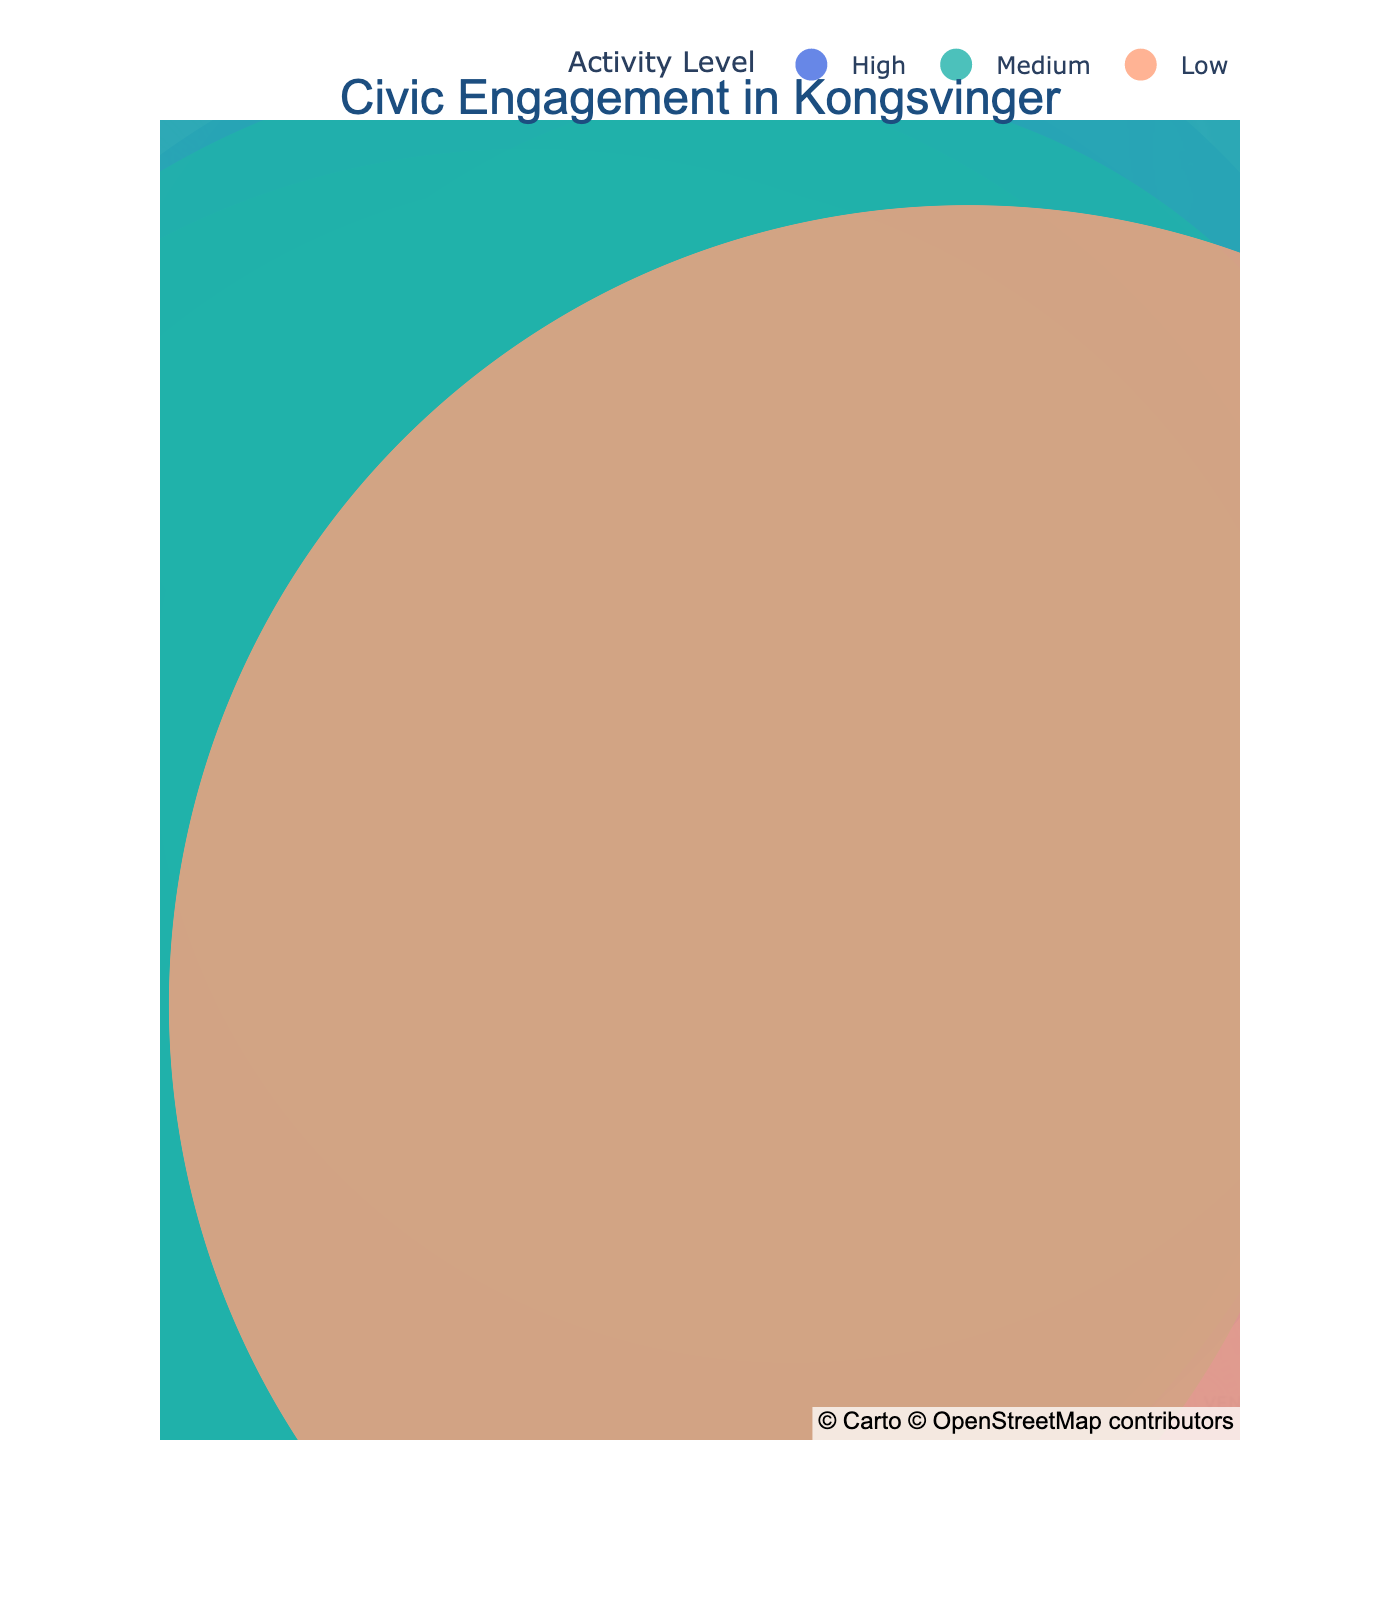What is the title of the map? The title of the map is displayed at the top center and reads "Civic Engagement in Kongsvinger".
Answer: Civic Engagement in Kongsvinger How many community centers have a high activity level? Look for the data points labeled as "Community Center" and with an "Activity Level" of "High". There are four such points: Kongsvinger Library, Øvrebyen Community House, Kongsvinger Youth Club, and Kongsvinger Senior Center.
Answer: 4 Which location is closest to the coordinates (60.1920, 11.9977)? The coordinates match the location of the Kongsvinger Library based on the data provided.
Answer: Kongsvinger Library How does the activity level of Kongsvinger Fortress Museum compare to that of Kongsvinger Town Hall? Kongsvinger Fortress Museum has a "Medium" activity level, while Kongsvinger Town Hall also has a "Medium" activity level.
Answer: Same Which type of center has the most high activity level locations? Examine the activity level for each type and identify that "Community Center" has the most high activity level locations: Kongsvinger Library, Øvrebyen Community House, Kongsvinger Youth Club, and Kongsvinger Senior Center.
Answer: Community Center What is the average latitude of community centers with a high activity level? The latitudes of the high activity level community centers are 60.1920, 60.1967, 60.1938, and 60.1932. Sum these values (240.7757) and divide by 4 (number of points) to get the average.
Answer: 60.1939 Which location has the lowest activity level? Observe the color scheme or hover over data points and identify that Liermoen Community Garden has the lowest activity level.
Answer: Liermoen Community Garden How many different types of centers are represented on the map? List all unique types: Community Center, Historical Site, Civic Building, Arts Venue, Green Space, Park, Sports Facility, Religious Center, and Volunteer Center. Count these types.
Answer: 9 Between Kongsvinger Cultural Center and Kongsvinger Sports Complex, which one is situated farther south? Compare the latitudes: Kongsvinger Cultural Center (60.1915) and Kongsvinger Sports Complex (60.1849). The Sports Complex has a lower latitude, indicating it is farther south.
Answer: Kongsvinger Sports Complex What is the total number of locations with a medium activity level? Identify and count the locations with the "Medium" activity level: Kongsvinger Fortress Museum, Kongsvinger Town Hall, Vinger Church, Kongsvinger Red Cross, and Gullbekkparken.
Answer: 5 